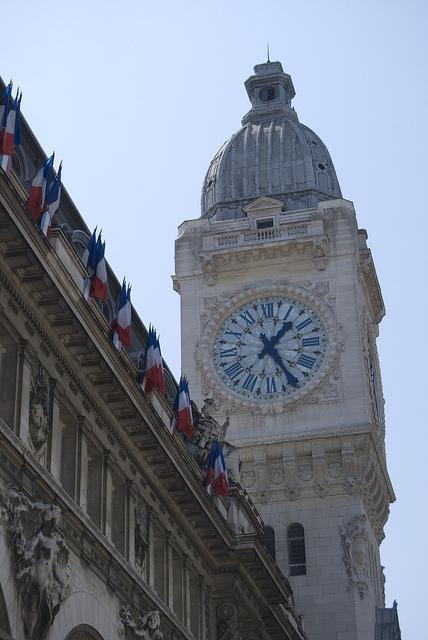How many people are performing a trick on a skateboard?
Give a very brief answer. 0. 